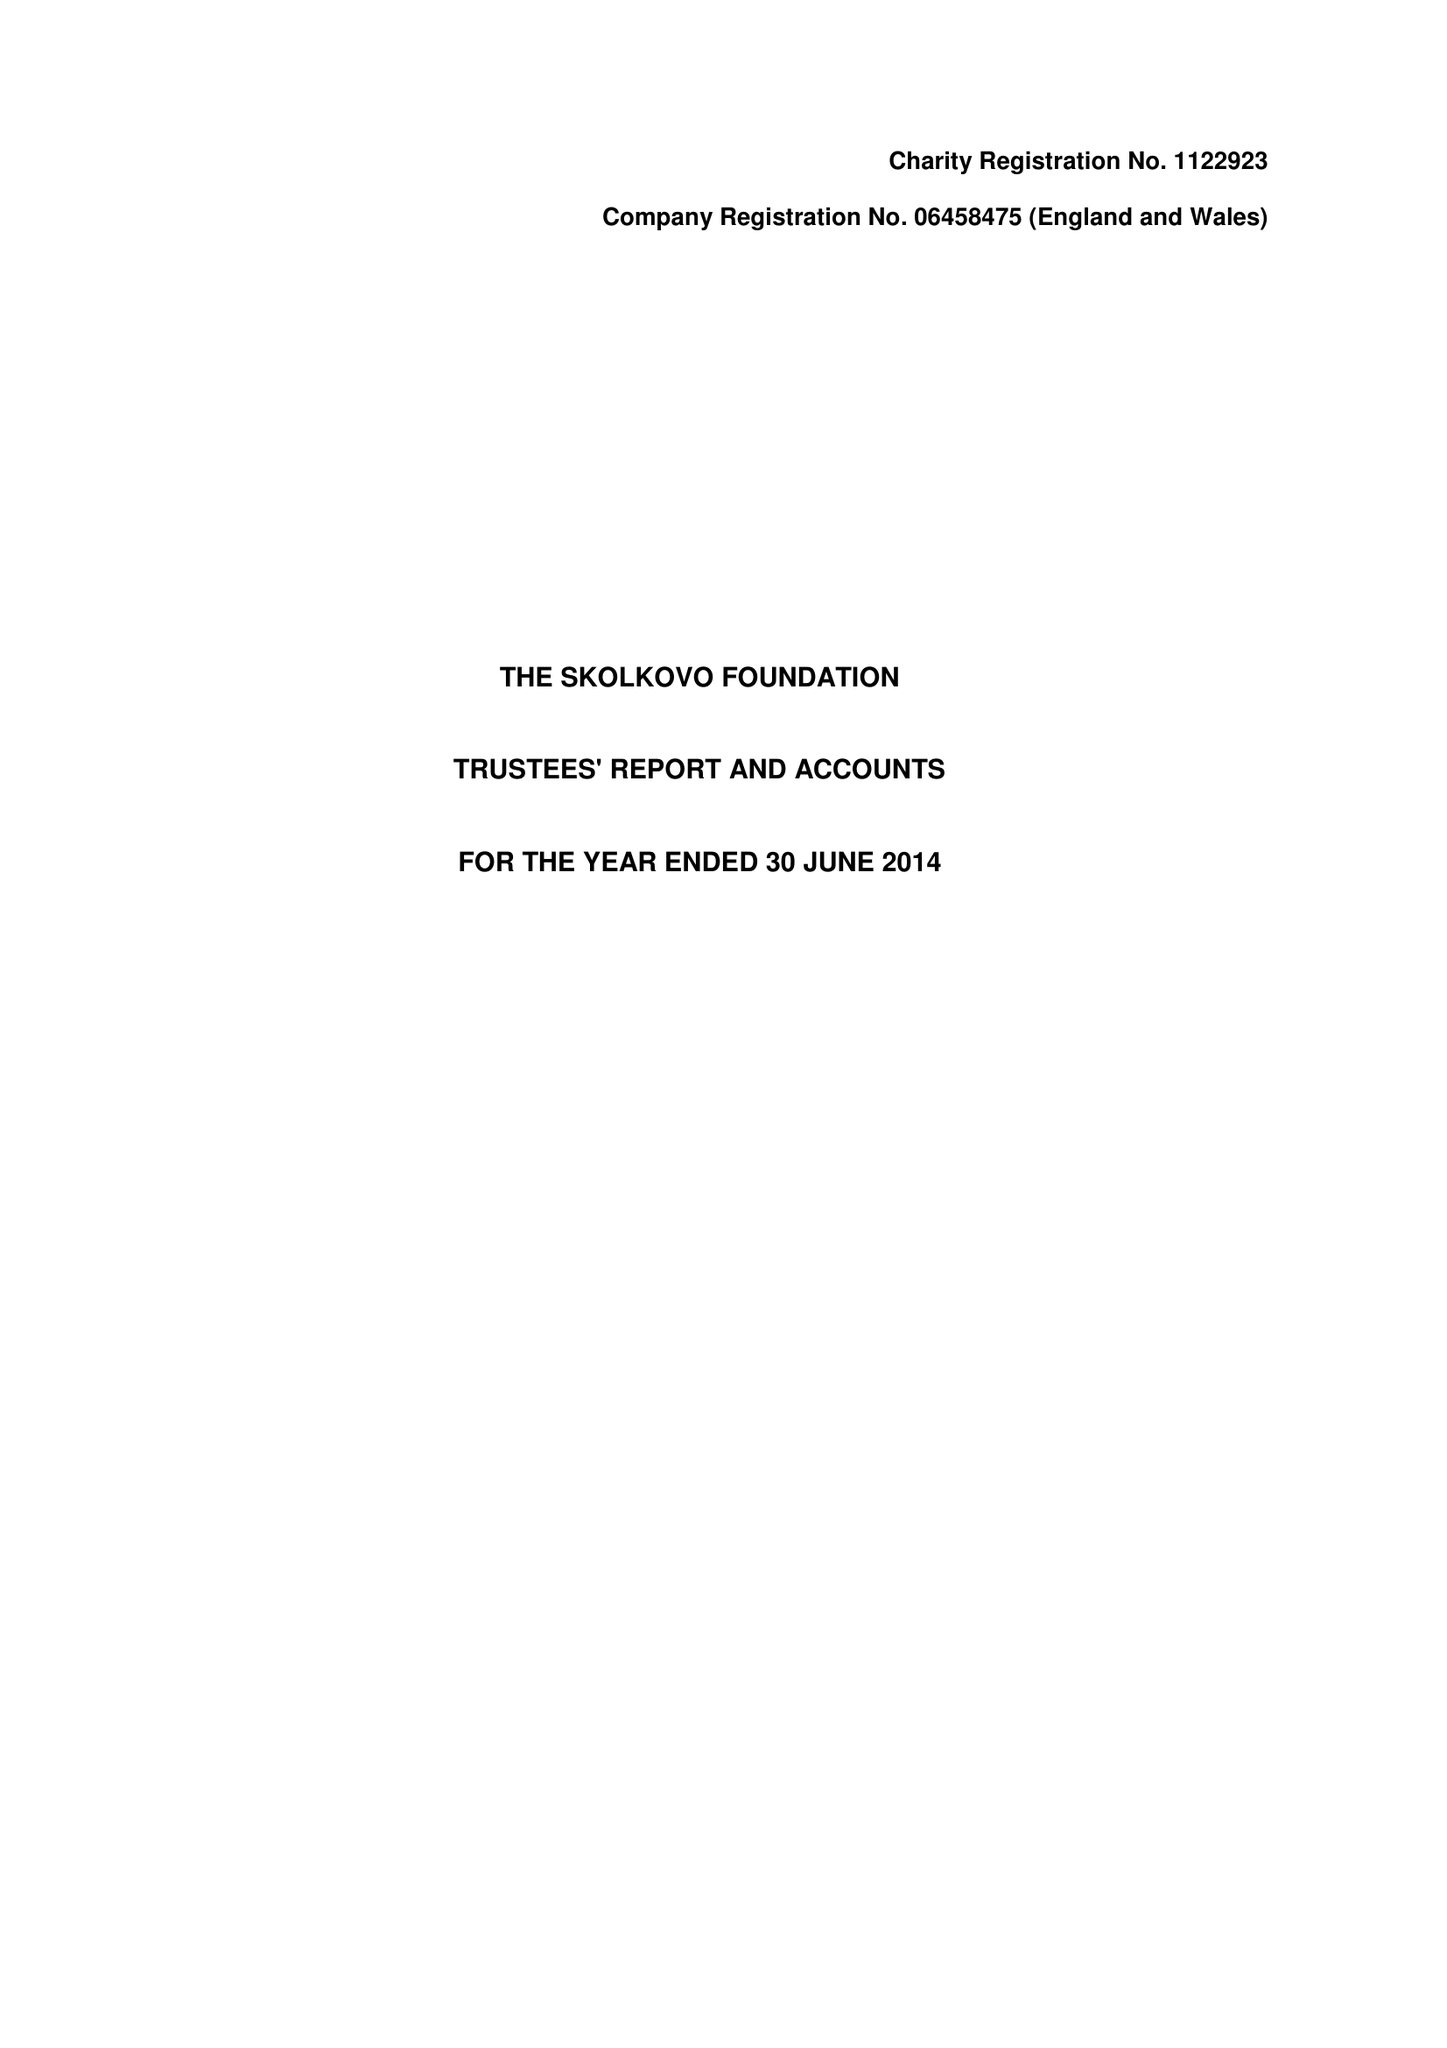What is the value for the income_annually_in_british_pounds?
Answer the question using a single word or phrase. 57279.00 